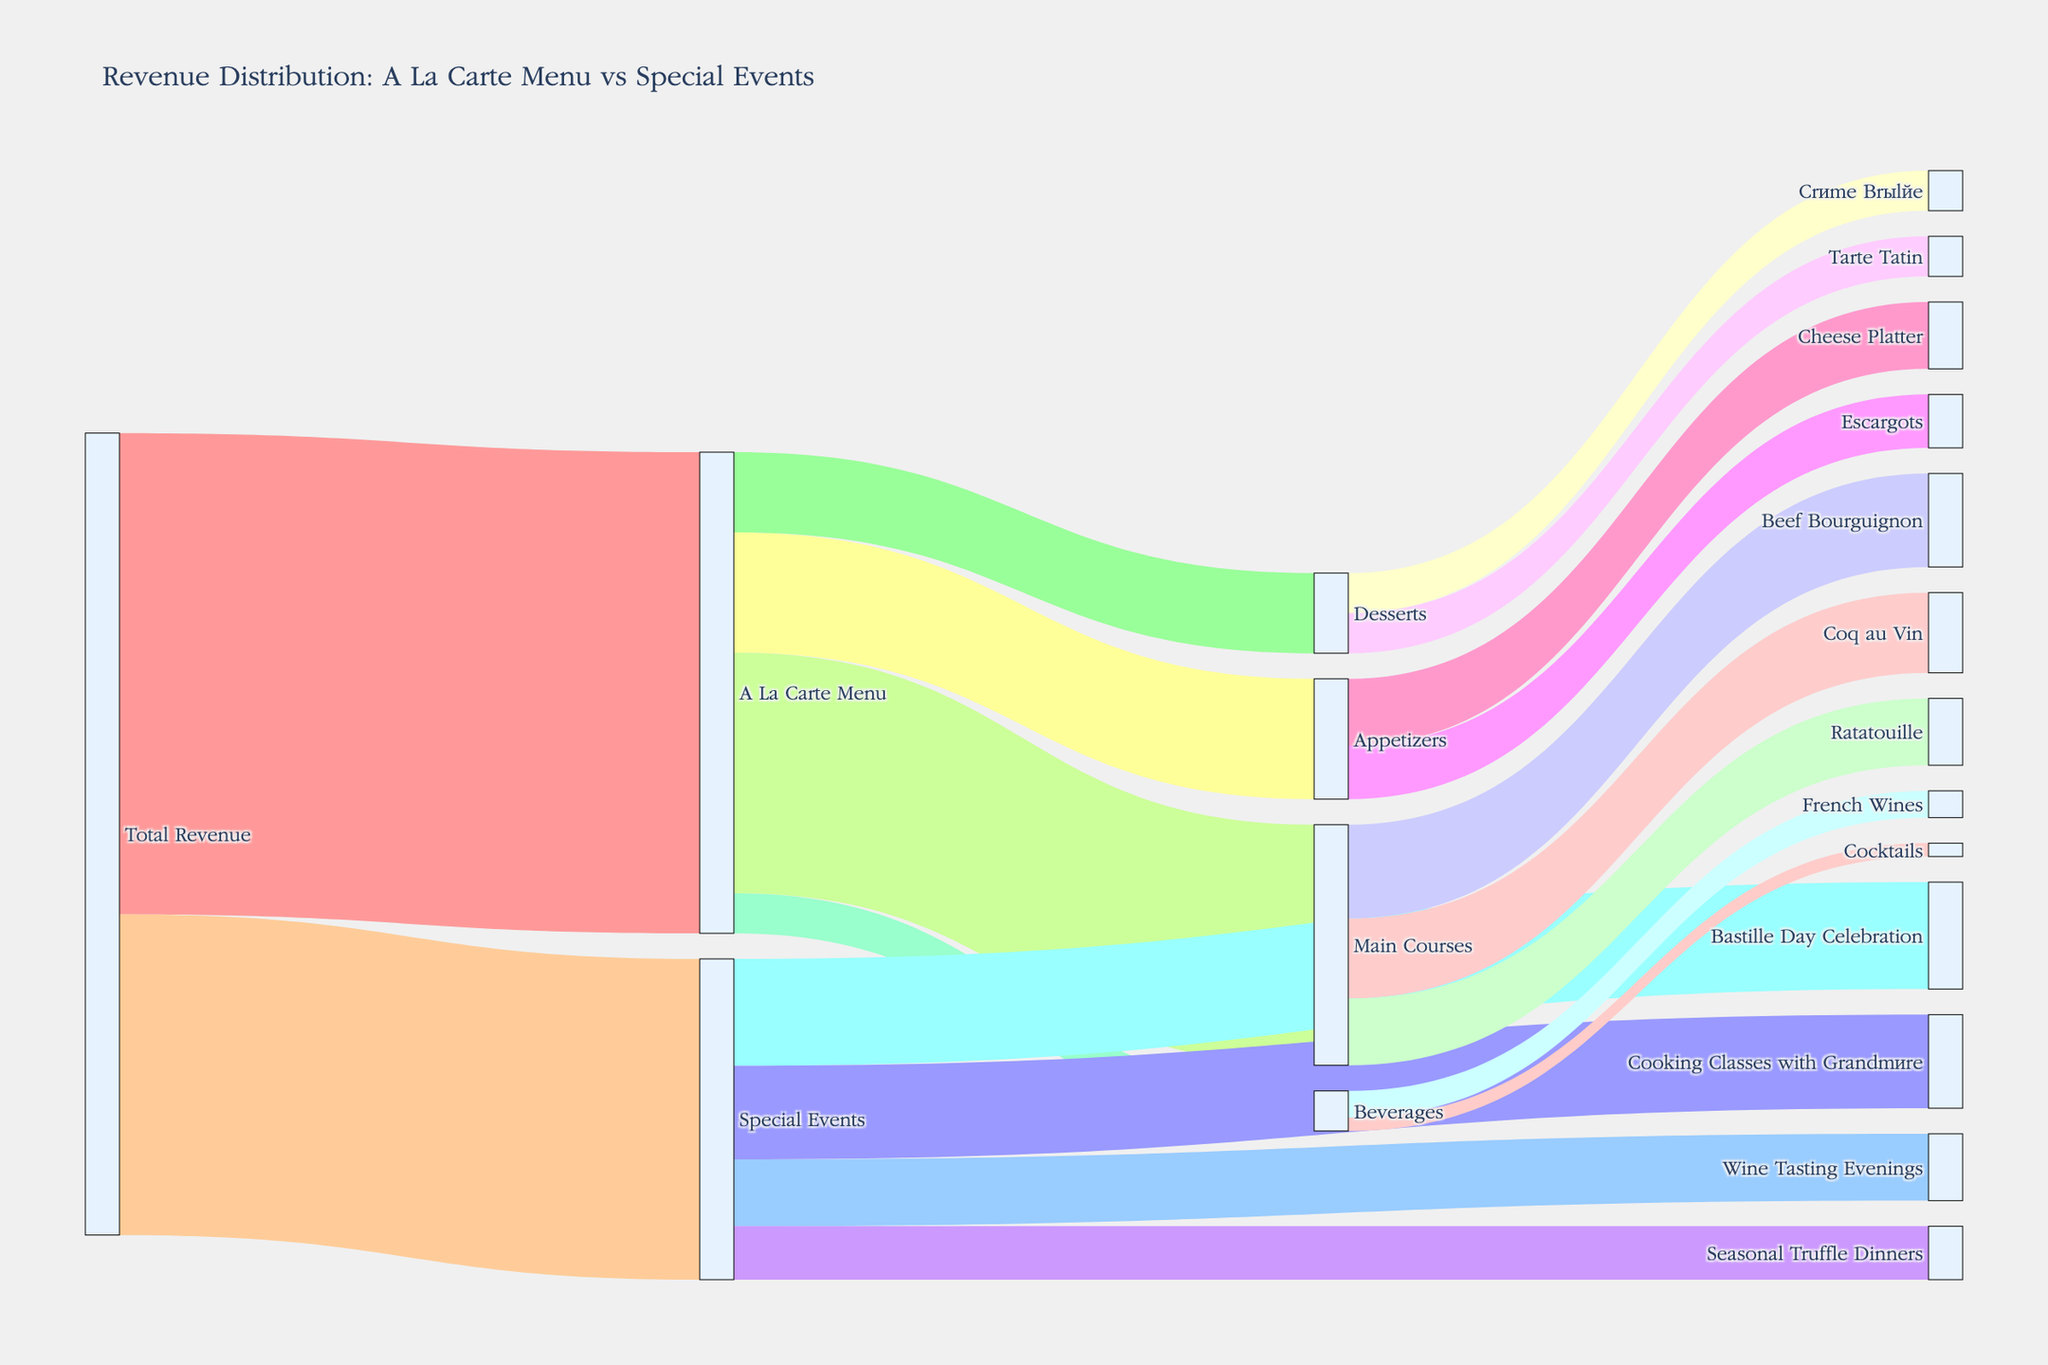What is the total revenue from Special Events? To find the total revenue from Special Events, look at the flow from Total Revenue to Special Events, which is indicated by the label "120,000".
Answer: 120,000 How much revenue do Appetizers contribute to the À La Carte Menu? To determine the contribution of Appetizers to the À La Carte Menu, look at the flow from À La Carte Menu to Appetizers, which is labeled as "45,000".
Answer: 45,000 Which is the highest revenue-generating activity under Special Events? To identify the highest revenue-generating activity, compare the values of all activities under Special Events: Bastille Day Celebration (40,000), Wine Tasting Evenings (25,000), Cooking Classes with Grandmère (35,000), and Seasonal Truffle Dinners (20,000). The highest value is for Bastille Day Celebration.
Answer: Bastille Day Celebration What is the combined revenue of Coq au Vin and Beef Bourguignon under Main Courses? To find the combined revenue, sum the revenues of Coq au Vin and Beef Bourguignon. Coq au Vin generates 30,000, and Beef Bourguignon generates 35,000. So, the combined revenue is 30,000 + 35,000 = 65,000.
Answer: 65,000 How does the revenue from Desserts compare to Beverages in the À La Carte Menu? Compare the total revenues flowing from À La Carte Menu to Desserts and Beverages. Desserts generate 30,000 while Beverages generate 15,000. Desserts bring in more revenue than Beverages.
Answer: Desserts have higher revenue than Beverages Which menu category contributes the most to the À La Carte Menu? To find the highest contributing category, compare the values of Appetizers (45,000), Main Courses (90,000), Desserts (30,000), and Beverages (15,000) under À La Carte Menu. The Main Courses category has the highest value.
Answer: Main Courses What percentage of the Special Events' revenue comes from Cooking Classes with Grandmère? To calculate the percentage, divide the revenue from Cooking Classes with Grandmère (35,000) by the total Special Events revenue (120,000) and multiply by 100. (35,000 / 120,000) * 100 ≈ 29.17%.
Answer: 29.17% Is the revenue from Escargots higher than the total revenue from Desserts? Compare the revenue from Escargots (20,000) with the total revenue from Desserts (30,000). The total revenue from Desserts is higher.
Answer: No What is the revenue difference between the Seasonal Truffle Dinners and Wine Tasting Evenings special events? Subtract the revenue of Seasonal Truffle Dinners (20,000) from Wine Tasting Evenings (25,000). The difference is 25,000 - 20,000 = 5,000.
Answer: 5,000 How much revenue does Tarte Tatin contribute individually? Examine the flow from Desserts to Tarte Tatin, which is labeled as "15,000".
Answer: 15,000 